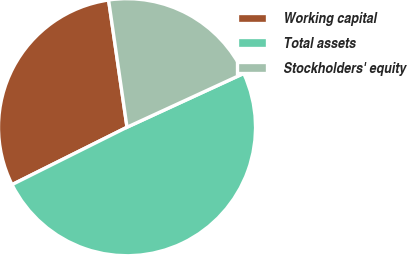Convert chart. <chart><loc_0><loc_0><loc_500><loc_500><pie_chart><fcel>Working capital<fcel>Total assets<fcel>Stockholders' equity<nl><fcel>30.08%<fcel>49.5%<fcel>20.42%<nl></chart> 